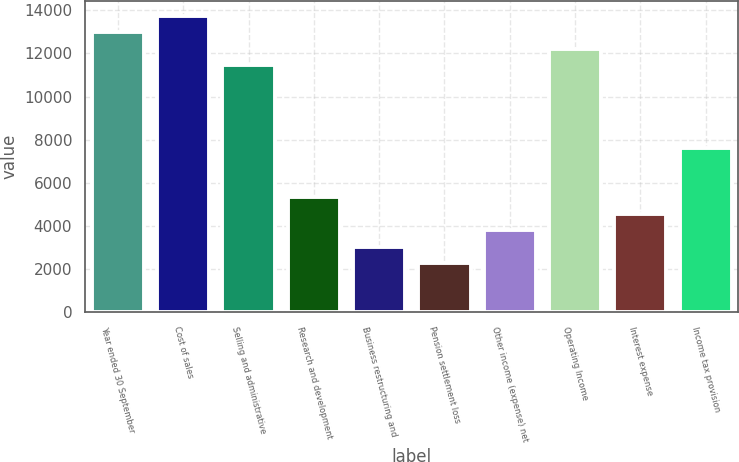Convert chart to OTSL. <chart><loc_0><loc_0><loc_500><loc_500><bar_chart><fcel>Year ended 30 September<fcel>Cost of sales<fcel>Selling and administrative<fcel>Research and development<fcel>Business restructuring and<fcel>Pension settlement loss<fcel>Other income (expense) net<fcel>Operating Income<fcel>Interest expense<fcel>Income tax provision<nl><fcel>12969.9<fcel>13732.7<fcel>11444.1<fcel>5341.35<fcel>3052.8<fcel>2289.95<fcel>3815.65<fcel>12207<fcel>4578.5<fcel>7629.9<nl></chart> 